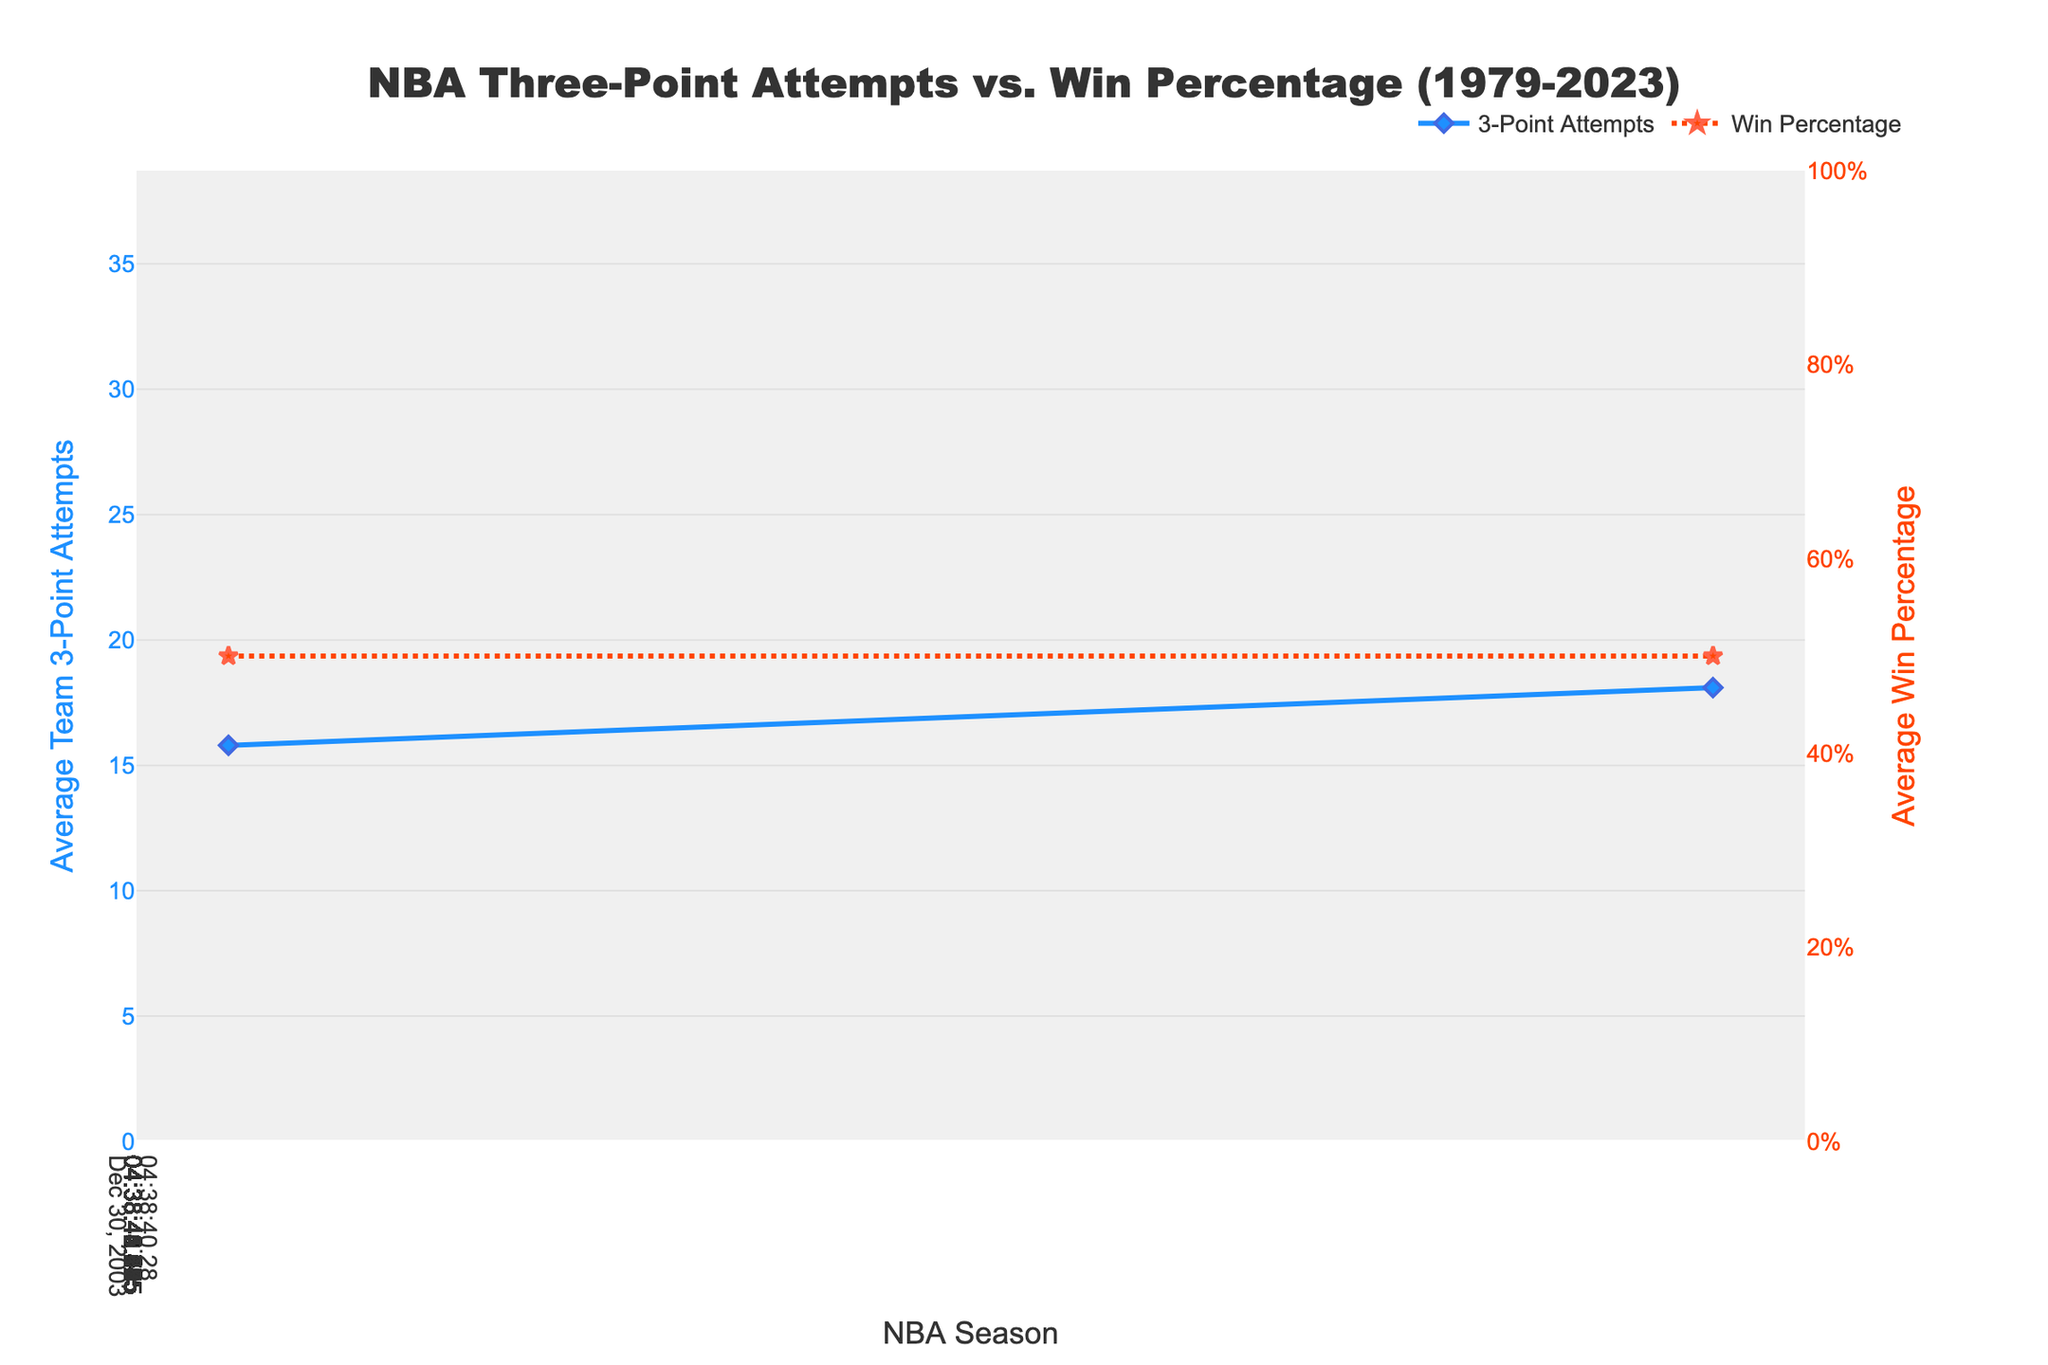What's the average number of three-point attempts in the 2010-2015 seasons? Look at the values for 2009-10, 2014-15, and average them: (18.1 + 22.4) / 2 = 20.25
Answer: 20.25 Which season had the highest average number of three-point attempts? Look for the maximum value in the "Average Team 3PA" column, it is 35.2 in 2021-22
Answer: 2021-22 Did the average win percentage ever change significantly across the seasons? No, the average win percentage remains constant at 0.500 for all seasons
Answer: No How does the number of three-point attempts in 1989-90 compare to 1979-80? In 1989-90, the average was 6.6 and in 1979-80 it was 2.8; 6.6 - 2.8 = 3.8
Answer: 3.8 more What is the trend in the average number of three-point attempts from 1979-2023? The trend shows a consistent increase in the number of three-point attempts over the years
Answer: Increasing What is the range of average three-point attempts from 1979-2023? The minimum value is 2.8 (1979-80) and the maximum value is 35.2 (2021-22); range = 35.2 - 2.8 = 32.4
Answer: 32.4 Is there a season where the average three-point attempts decreased compared to the previous season? Yes, from 1994-95 (15.3) to 1999-00 (13.7)
Answer: 1999-00 How much did the average three-point attempts increase from 1999-00 to 2019-20? The value for 1999-00 is 13.7 and for 2019-20 it is 34.1; increase = 34.1 - 13.7 = 20.4
Answer: 20.4 What is the average three-point attempts over the two decades from 2000-2020? Adding the values from 1999-00, 2004-05, 2009-10, 2014-15, 2019-20 and dividing by 5; (13.7 + 15.8 + 18.1 + 22.4 + 34.1) / 5 = 20.82
Answer: 20.82 